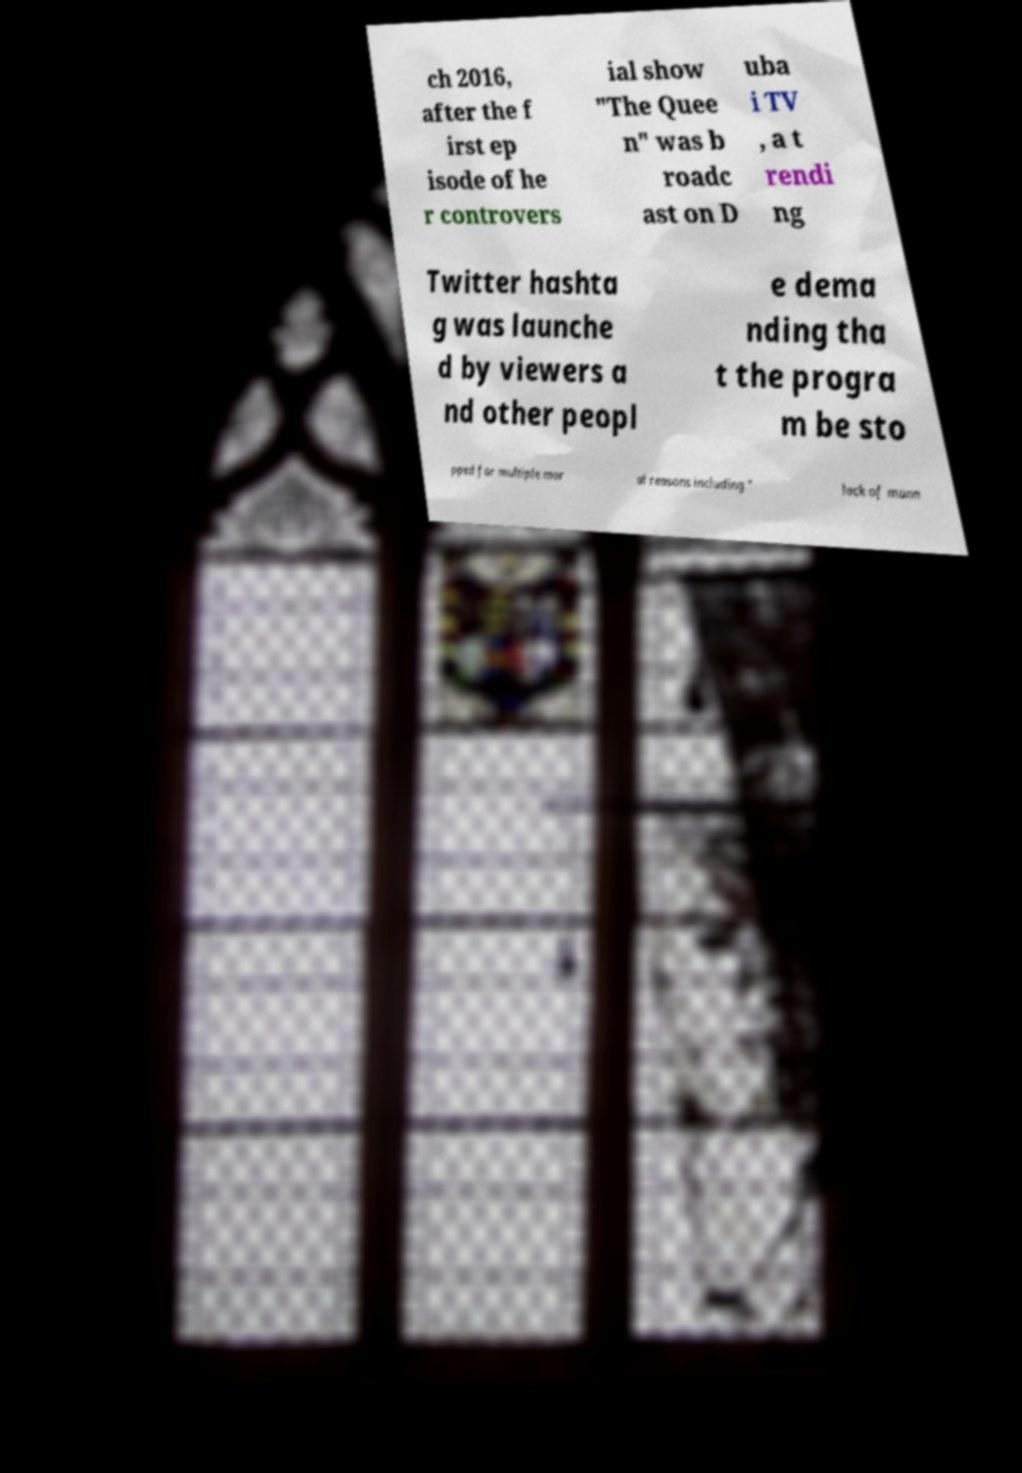Can you accurately transcribe the text from the provided image for me? ch 2016, after the f irst ep isode of he r controvers ial show "The Quee n" was b roadc ast on D uba i TV , a t rendi ng Twitter hashta g was launche d by viewers a nd other peopl e dema nding tha t the progra m be sto pped for multiple mor al reasons including " lack of mann 